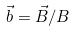Convert formula to latex. <formula><loc_0><loc_0><loc_500><loc_500>\vec { b } = \vec { B } / B</formula> 